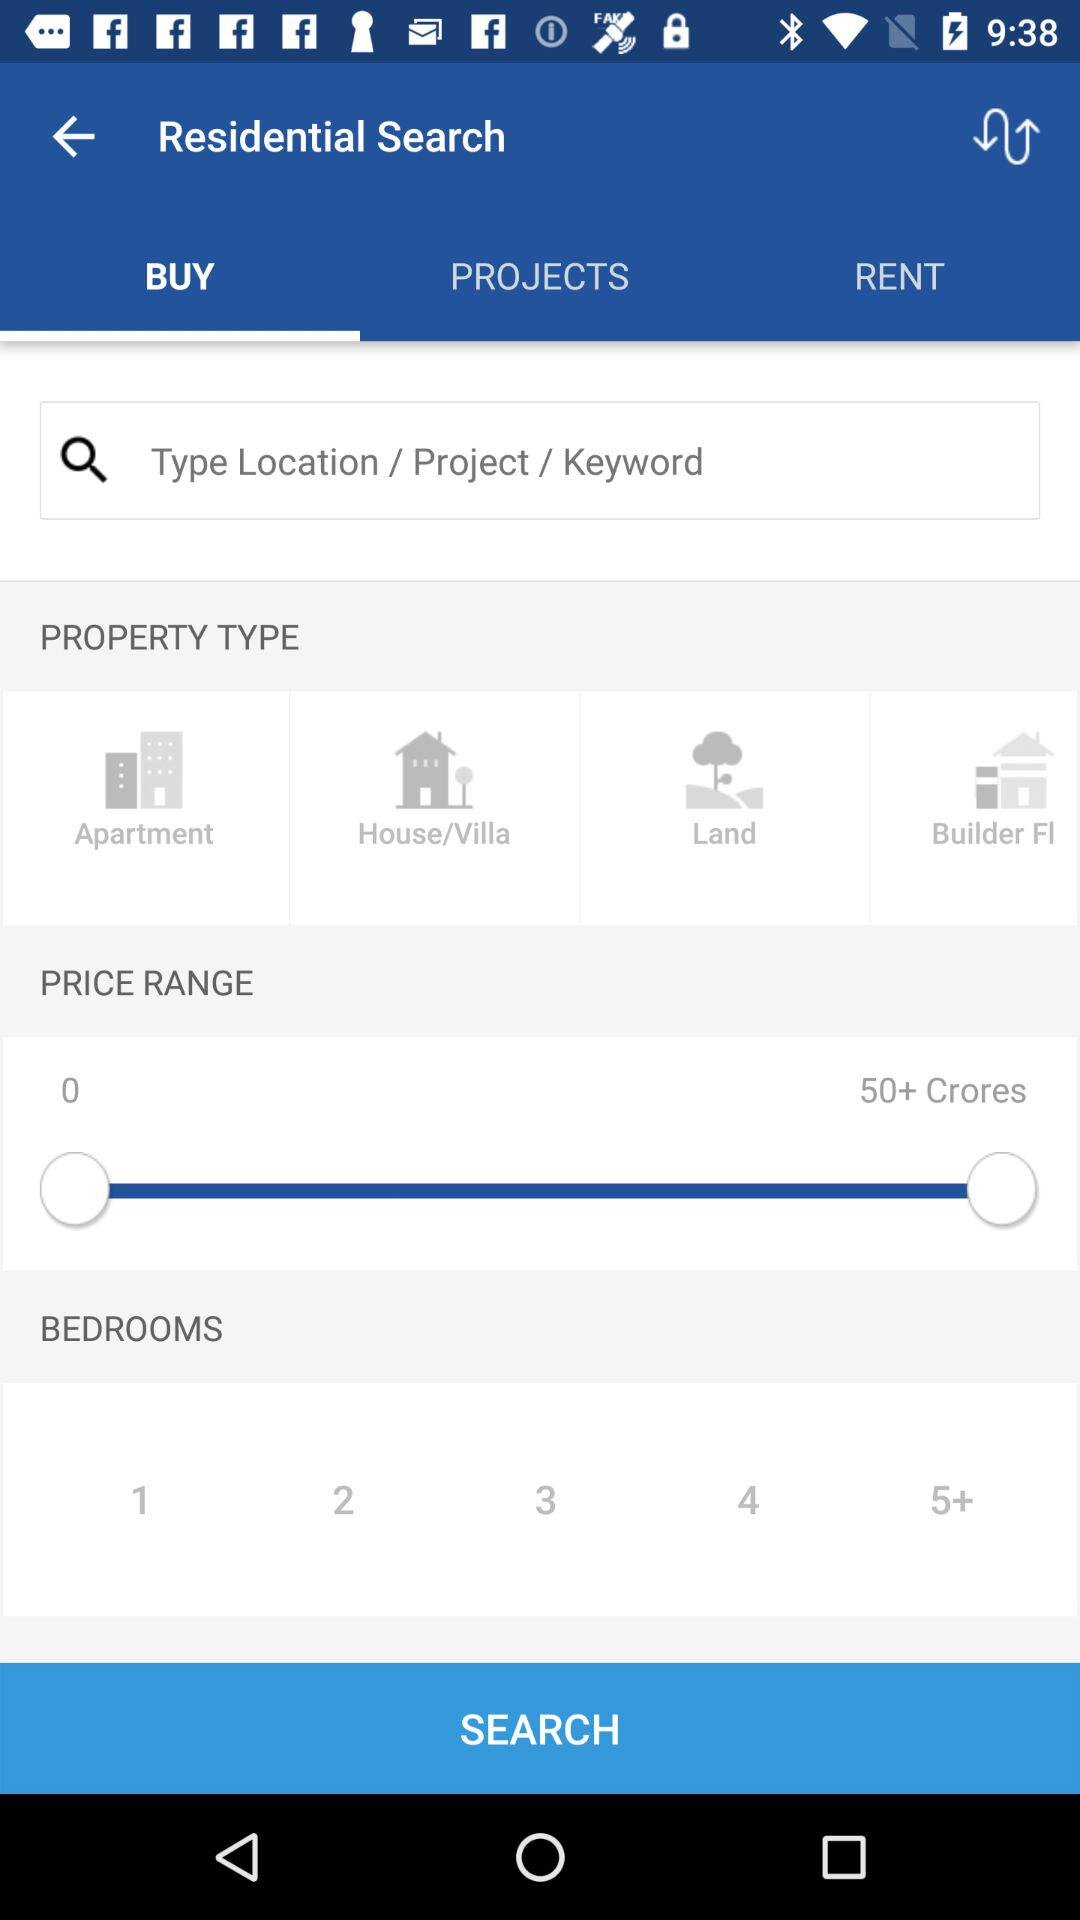What is the selected tab? The selected tab is "BUY". 